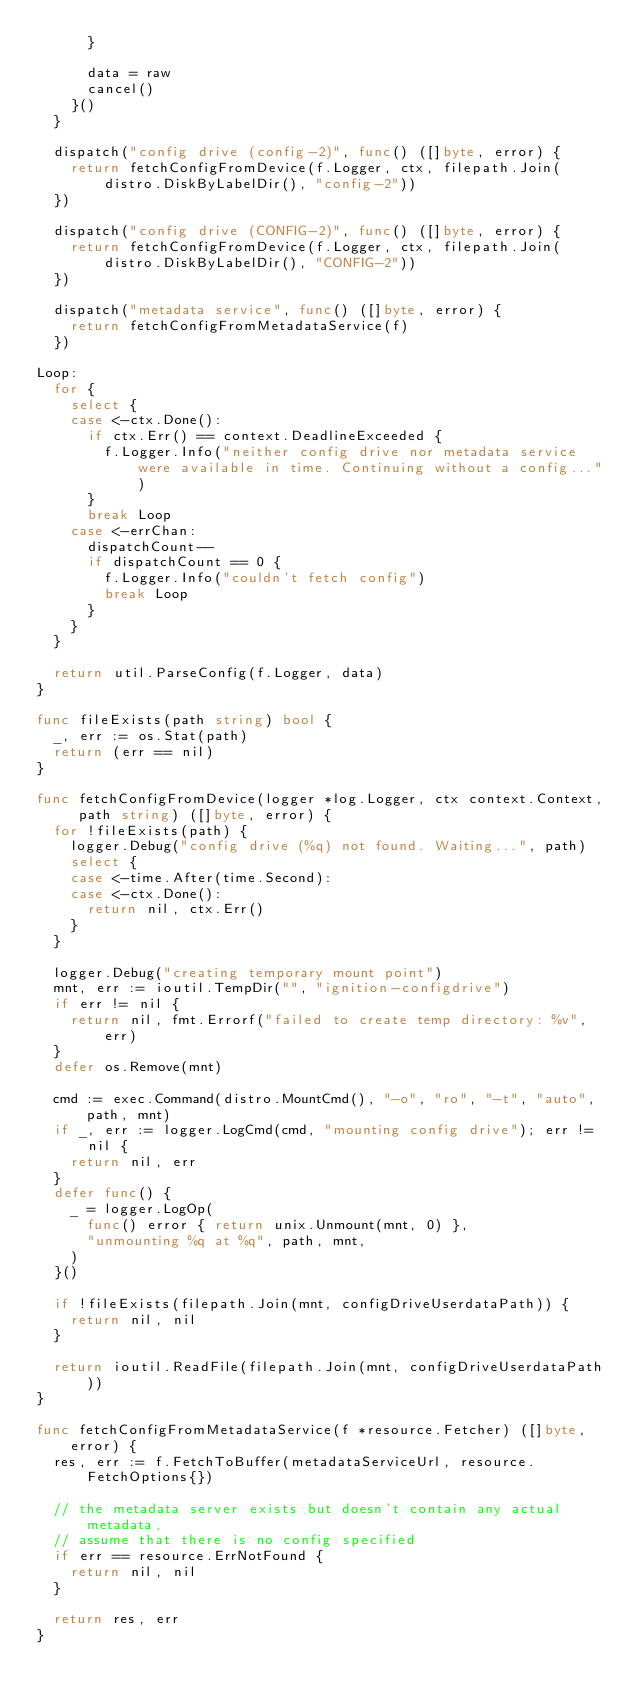<code> <loc_0><loc_0><loc_500><loc_500><_Go_>			}

			data = raw
			cancel()
		}()
	}

	dispatch("config drive (config-2)", func() ([]byte, error) {
		return fetchConfigFromDevice(f.Logger, ctx, filepath.Join(distro.DiskByLabelDir(), "config-2"))
	})

	dispatch("config drive (CONFIG-2)", func() ([]byte, error) {
		return fetchConfigFromDevice(f.Logger, ctx, filepath.Join(distro.DiskByLabelDir(), "CONFIG-2"))
	})

	dispatch("metadata service", func() ([]byte, error) {
		return fetchConfigFromMetadataService(f)
	})

Loop:
	for {
		select {
		case <-ctx.Done():
			if ctx.Err() == context.DeadlineExceeded {
				f.Logger.Info("neither config drive nor metadata service were available in time. Continuing without a config...")
			}
			break Loop
		case <-errChan:
			dispatchCount--
			if dispatchCount == 0 {
				f.Logger.Info("couldn't fetch config")
				break Loop
			}
		}
	}

	return util.ParseConfig(f.Logger, data)
}

func fileExists(path string) bool {
	_, err := os.Stat(path)
	return (err == nil)
}

func fetchConfigFromDevice(logger *log.Logger, ctx context.Context, path string) ([]byte, error) {
	for !fileExists(path) {
		logger.Debug("config drive (%q) not found. Waiting...", path)
		select {
		case <-time.After(time.Second):
		case <-ctx.Done():
			return nil, ctx.Err()
		}
	}

	logger.Debug("creating temporary mount point")
	mnt, err := ioutil.TempDir("", "ignition-configdrive")
	if err != nil {
		return nil, fmt.Errorf("failed to create temp directory: %v", err)
	}
	defer os.Remove(mnt)

	cmd := exec.Command(distro.MountCmd(), "-o", "ro", "-t", "auto", path, mnt)
	if _, err := logger.LogCmd(cmd, "mounting config drive"); err != nil {
		return nil, err
	}
	defer func() {
		_ = logger.LogOp(
			func() error { return unix.Unmount(mnt, 0) },
			"unmounting %q at %q", path, mnt,
		)
	}()

	if !fileExists(filepath.Join(mnt, configDriveUserdataPath)) {
		return nil, nil
	}

	return ioutil.ReadFile(filepath.Join(mnt, configDriveUserdataPath))
}

func fetchConfigFromMetadataService(f *resource.Fetcher) ([]byte, error) {
	res, err := f.FetchToBuffer(metadataServiceUrl, resource.FetchOptions{})

	// the metadata server exists but doesn't contain any actual metadata,
	// assume that there is no config specified
	if err == resource.ErrNotFound {
		return nil, nil
	}

	return res, err
}
</code> 